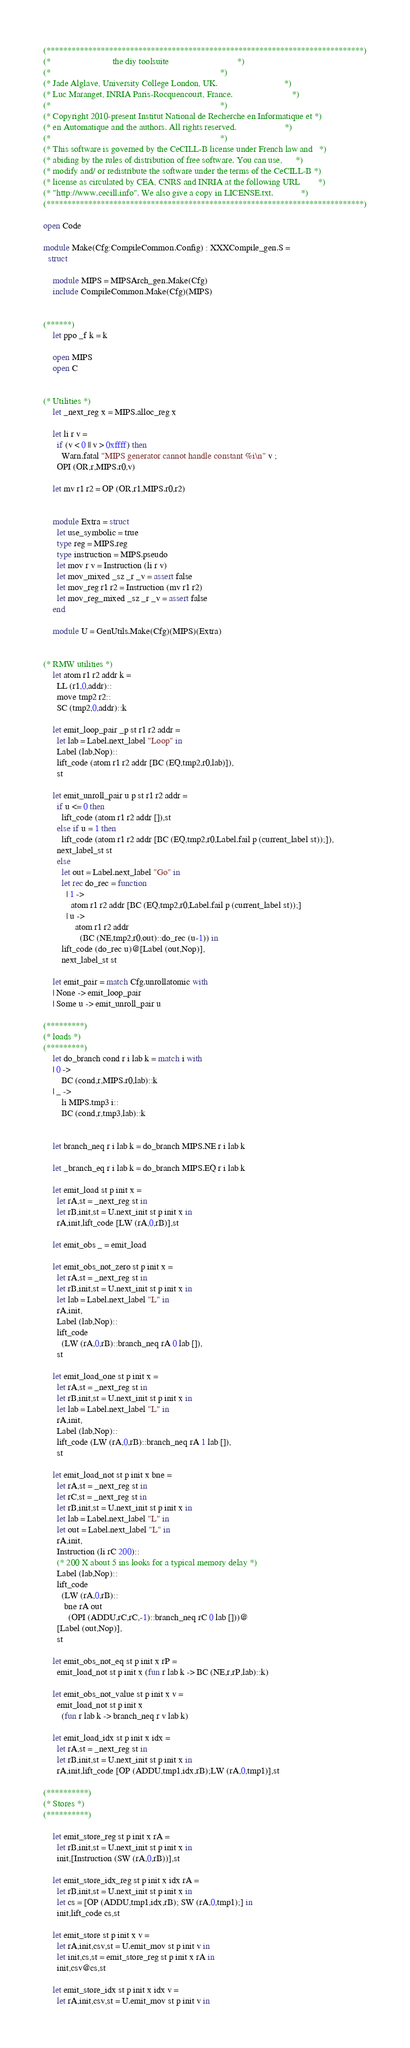Convert code to text. <code><loc_0><loc_0><loc_500><loc_500><_OCaml_>(****************************************************************************)
(*                           the diy toolsuite                              *)
(*                                                                          *)
(* Jade Alglave, University College London, UK.                             *)
(* Luc Maranget, INRIA Paris-Rocquencourt, France.                          *)
(*                                                                          *)
(* Copyright 2010-present Institut National de Recherche en Informatique et *)
(* en Automatique and the authors. All rights reserved.                     *)
(*                                                                          *)
(* This software is governed by the CeCILL-B license under French law and   *)
(* abiding by the rules of distribution of free software. You can use,      *)
(* modify and/ or redistribute the software under the terms of the CeCILL-B *)
(* license as circulated by CEA, CNRS and INRIA at the following URL        *)
(* "http://www.cecill.info". We also give a copy in LICENSE.txt.            *)
(****************************************************************************)

open Code

module Make(Cfg:CompileCommon.Config) : XXXCompile_gen.S =
  struct

    module MIPS = MIPSArch_gen.Make(Cfg)
    include CompileCommon.Make(Cfg)(MIPS)


(******)
    let ppo _f k = k

    open MIPS
    open C


(* Utilities *)
    let _next_reg x = MIPS.alloc_reg x

    let li r v =
      if (v < 0 || v > 0xffff) then
        Warn.fatal "MIPS generator cannot handle constant %i\n" v ;
      OPI (OR,r,MIPS.r0,v)

    let mv r1 r2 = OP (OR,r1,MIPS.r0,r2)


    module Extra = struct
      let use_symbolic = true
      type reg = MIPS.reg
      type instruction = MIPS.pseudo
      let mov r v = Instruction (li r v)
      let mov_mixed _sz _r _v = assert false
      let mov_reg r1 r2 = Instruction (mv r1 r2)
      let mov_reg_mixed _sz _r _v = assert false
    end

    module U = GenUtils.Make(Cfg)(MIPS)(Extra)


(* RMW utilities *)
    let atom r1 r2 addr k =
      LL (r1,0,addr)::
      move tmp2 r2::
      SC (tmp2,0,addr)::k

    let emit_loop_pair _p st r1 r2 addr =
      let lab = Label.next_label "Loop" in
      Label (lab,Nop)::
      lift_code (atom r1 r2 addr [BC (EQ,tmp2,r0,lab)]),
      st

    let emit_unroll_pair u p st r1 r2 addr =
      if u <= 0 then
        lift_code (atom r1 r2 addr []),st
      else if u = 1 then
        lift_code (atom r1 r2 addr [BC (EQ,tmp2,r0,Label.fail p (current_label st));]),
      next_label_st st
      else
        let out = Label.next_label "Go" in
        let rec do_rec = function
          | 1 ->
            atom r1 r2 addr [BC (EQ,tmp2,r0,Label.fail p (current_label st));]
          | u ->
              atom r1 r2 addr
                (BC (NE,tmp2,r0,out)::do_rec (u-1)) in
        lift_code (do_rec u)@[Label (out,Nop)],
        next_label_st st

    let emit_pair = match Cfg.unrollatomic with
    | None -> emit_loop_pair
    | Some u -> emit_unroll_pair u

(*********)
(* loads *)
(*********)
    let do_branch cond r i lab k = match i with
    | 0 ->
        BC (cond,r,MIPS.r0,lab)::k
    | _ ->
        li MIPS.tmp3 i::
        BC (cond,r,tmp3,lab)::k


    let branch_neq r i lab k = do_branch MIPS.NE r i lab k

    let _branch_eq r i lab k = do_branch MIPS.EQ r i lab k

    let emit_load st p init x =
      let rA,st = _next_reg st in
      let rB,init,st = U.next_init st p init x in
      rA,init,lift_code [LW (rA,0,rB)],st

    let emit_obs _ = emit_load

    let emit_obs_not_zero st p init x =
      let rA,st = _next_reg st in
      let rB,init,st = U.next_init st p init x in
      let lab = Label.next_label "L" in
      rA,init,
      Label (lab,Nop)::
      lift_code
        (LW (rA,0,rB)::branch_neq rA 0 lab []),
      st

    let emit_load_one st p init x =
      let rA,st = _next_reg st in
      let rB,init,st = U.next_init st p init x in
      let lab = Label.next_label "L" in
      rA,init,
      Label (lab,Nop)::
      lift_code (LW (rA,0,rB)::branch_neq rA 1 lab []),
      st

    let emit_load_not st p init x bne =
      let rA,st = _next_reg st in
      let rC,st = _next_reg st in
      let rB,init,st = U.next_init st p init x in
      let lab = Label.next_label "L" in
      let out = Label.next_label "L" in
      rA,init,
      Instruction (li rC 200)::
      (* 200 X about 5 ins looks for a typical memory delay *)
      Label (lab,Nop)::
      lift_code
        (LW (rA,0,rB)::
         bne rA out
           (OPI (ADDU,rC,rC,-1)::branch_neq rC 0 lab []))@
      [Label (out,Nop)],
      st

    let emit_obs_not_eq st p init x rP =
      emit_load_not st p init x (fun r lab k -> BC (NE,r,rP,lab)::k)

    let emit_obs_not_value st p init x v =
      emit_load_not st p init x
        (fun r lab k -> branch_neq r v lab k)

    let emit_load_idx st p init x idx =
      let rA,st = _next_reg st in
      let rB,init,st = U.next_init st p init x in
      rA,init,lift_code [OP (ADDU,tmp1,idx,rB);LW (rA,0,tmp1)],st

(**********)
(* Stores *)
(**********)

    let emit_store_reg st p init x rA =
      let rB,init,st = U.next_init st p init x in
      init,[Instruction (SW (rA,0,rB))],st

    let emit_store_idx_reg st p init x idx rA =
      let rB,init,st = U.next_init st p init x in
      let cs = [OP (ADDU,tmp1,idx,rB); SW (rA,0,tmp1);] in
      init,lift_code cs,st

    let emit_store st p init x v =
      let rA,init,csv,st = U.emit_mov st p init v in
      let init,cs,st = emit_store_reg st p init x rA in
      init,csv@cs,st

    let emit_store_idx st p init x idx v =
      let rA,init,csv,st = U.emit_mov st p init v in</code> 